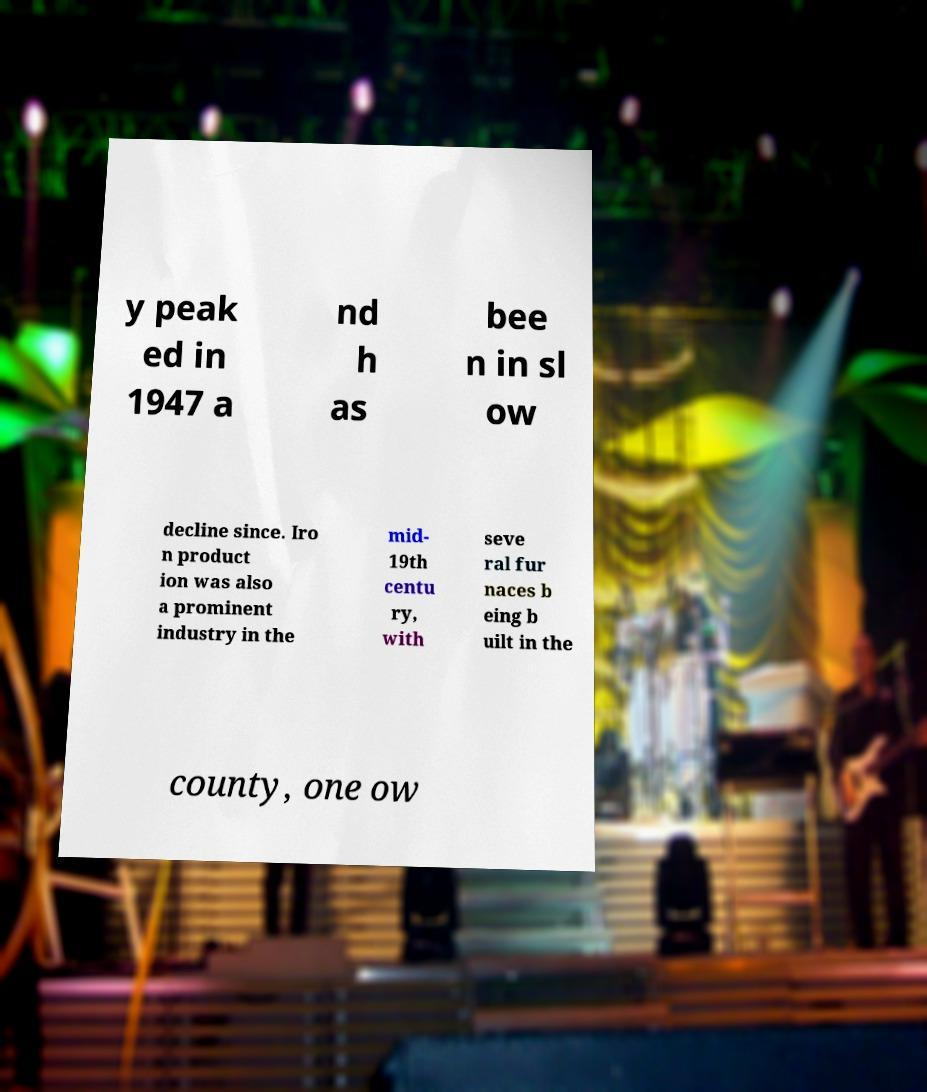Can you read and provide the text displayed in the image?This photo seems to have some interesting text. Can you extract and type it out for me? y peak ed in 1947 a nd h as bee n in sl ow decline since. Iro n product ion was also a prominent industry in the mid- 19th centu ry, with seve ral fur naces b eing b uilt in the county, one ow 